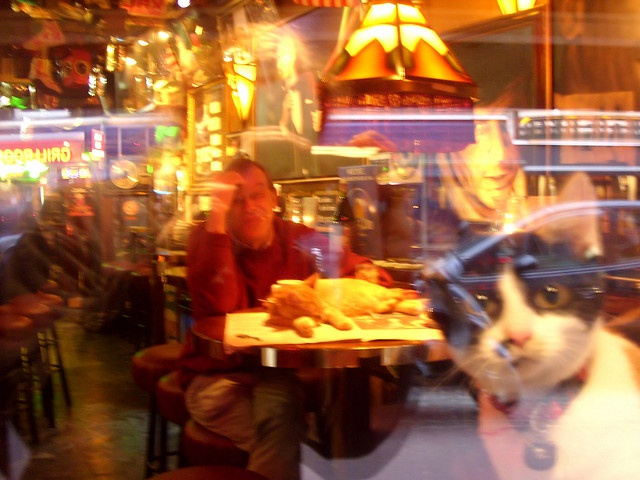Describe the objects in this image and their specific colors. I can see cat in maroon, lightyellow, khaki, tan, and brown tones, people in maroon and red tones, dining table in maroon, khaki, and orange tones, cat in maroon, orange, gold, red, and yellow tones, and chair in maroon and black tones in this image. 